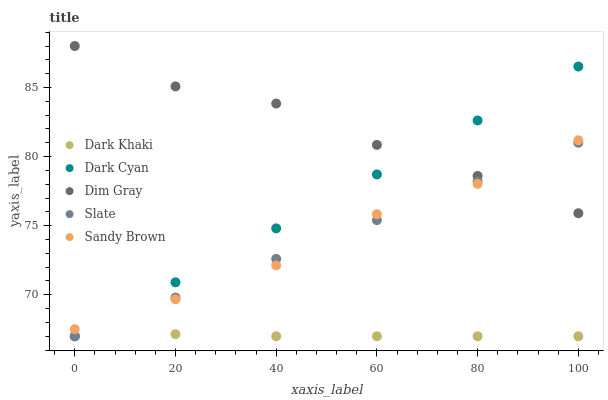Does Dark Khaki have the minimum area under the curve?
Answer yes or no. Yes. Does Dim Gray have the maximum area under the curve?
Answer yes or no. Yes. Does Dark Cyan have the minimum area under the curve?
Answer yes or no. No. Does Dark Cyan have the maximum area under the curve?
Answer yes or no. No. Is Slate the smoothest?
Answer yes or no. Yes. Is Dim Gray the roughest?
Answer yes or no. Yes. Is Dark Cyan the smoothest?
Answer yes or no. No. Is Dark Cyan the roughest?
Answer yes or no. No. Does Dark Khaki have the lowest value?
Answer yes or no. Yes. Does Dim Gray have the lowest value?
Answer yes or no. No. Does Dim Gray have the highest value?
Answer yes or no. Yes. Does Dark Cyan have the highest value?
Answer yes or no. No. Is Dark Khaki less than Sandy Brown?
Answer yes or no. Yes. Is Sandy Brown greater than Dark Khaki?
Answer yes or no. Yes. Does Sandy Brown intersect Dim Gray?
Answer yes or no. Yes. Is Sandy Brown less than Dim Gray?
Answer yes or no. No. Is Sandy Brown greater than Dim Gray?
Answer yes or no. No. Does Dark Khaki intersect Sandy Brown?
Answer yes or no. No. 